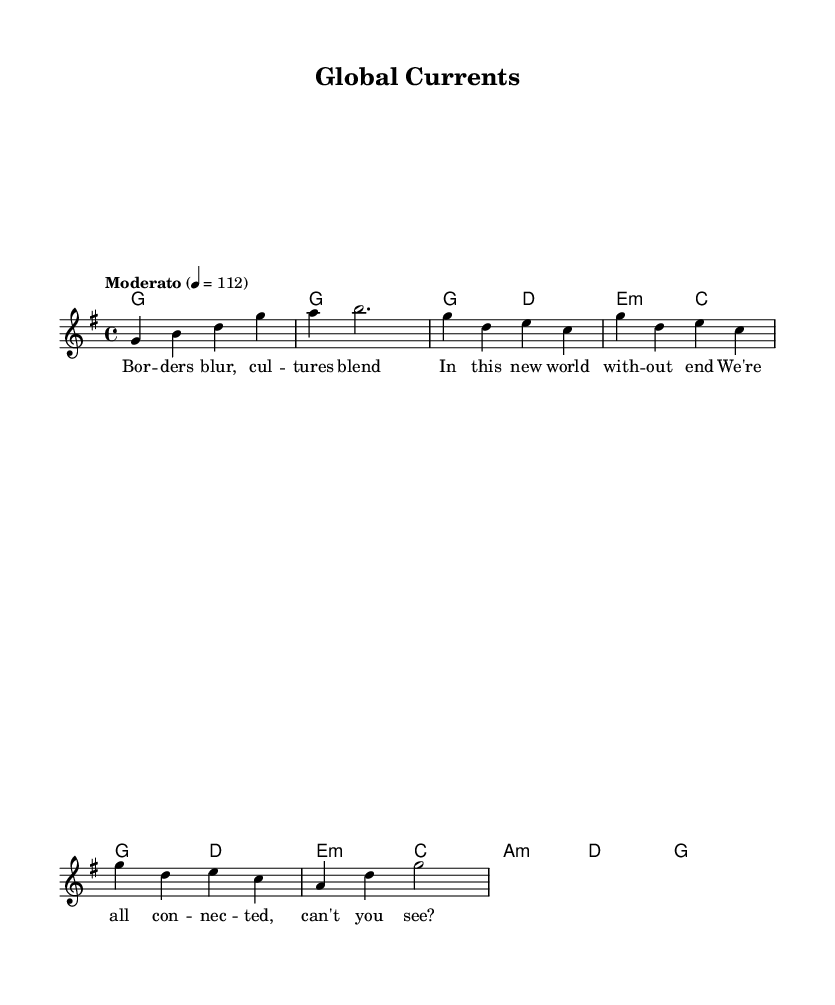What is the key signature of this music? The key signature appears at the beginning of the staff and indicates the key of G major, which has one sharp (F#).
Answer: G major What is the time signature? The time signature is found at the beginning of the piece, indicating the rhythmic structure of the music, which shows that there are four beats per measure.
Answer: 4/4 What is the tempo marking for this piece? The tempo marking is provided in a text format above the staff and specifies the speed at which the music should be played; it indicates a moderate pace of 112 beats per minute.
Answer: Moderato What is the last chord in the composition? The last chord is determined by looking at the final measure in the harmonies, which shows that it resolves to a G major chord.
Answer: G How many verses are in the lyrics provided? To determine the number of verses, we can count the distinct sets of lyrics in the sheet music; here there is one distinct verse followed by a chorus.
Answer: 1 What theme does the chorus suggest? The lyrics in the chorus indicate themes of connectivity and unity among humanity, suggesting the tapestry of human experience.
Answer: Connectivity 